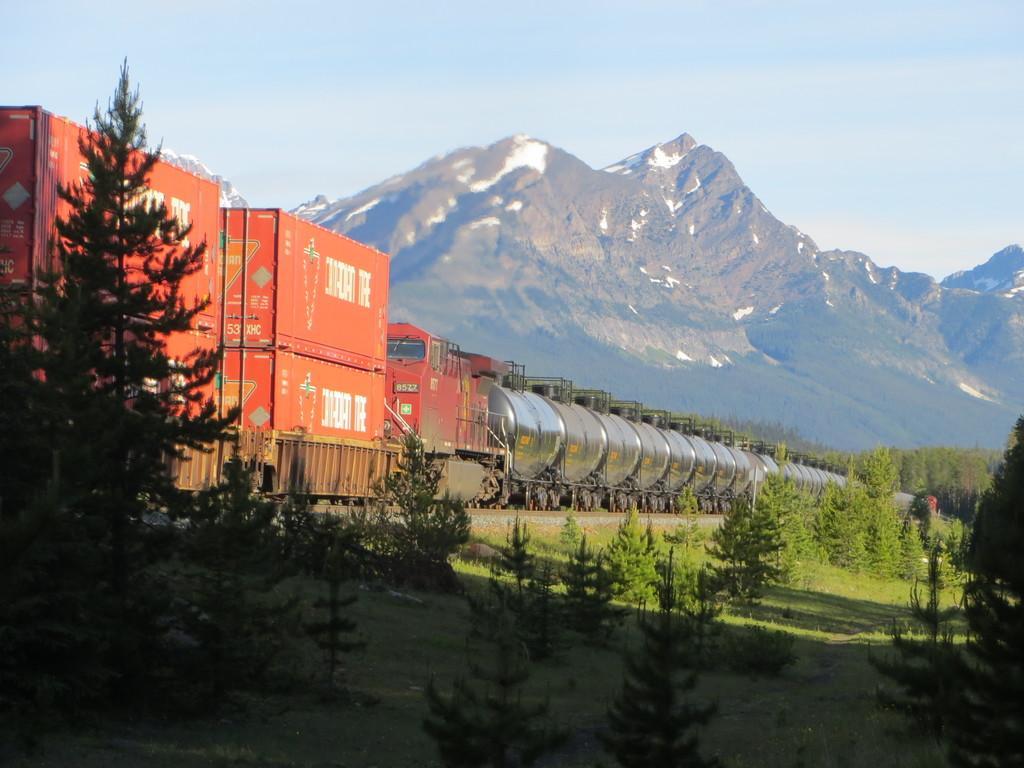Could you give a brief overview of what you see in this image? In this image we can see a goods train is moving on the railway track. This part of the image is dark, where we can see trees, grassland, mountains and the pale blue color sky in the background. 